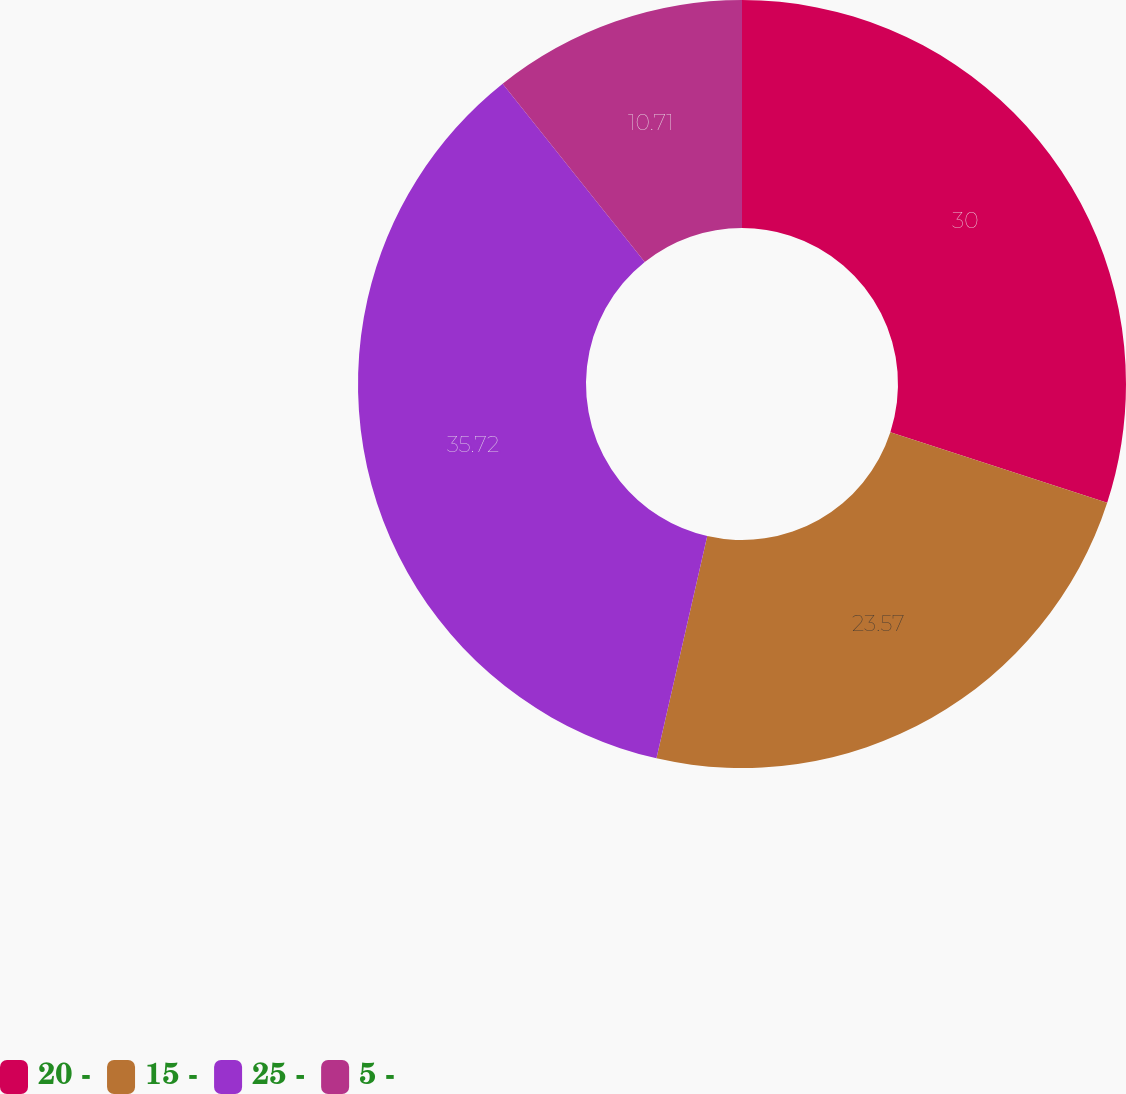Convert chart. <chart><loc_0><loc_0><loc_500><loc_500><pie_chart><fcel>20 -<fcel>15 -<fcel>25 -<fcel>5 -<nl><fcel>30.0%<fcel>23.57%<fcel>35.71%<fcel>10.71%<nl></chart> 